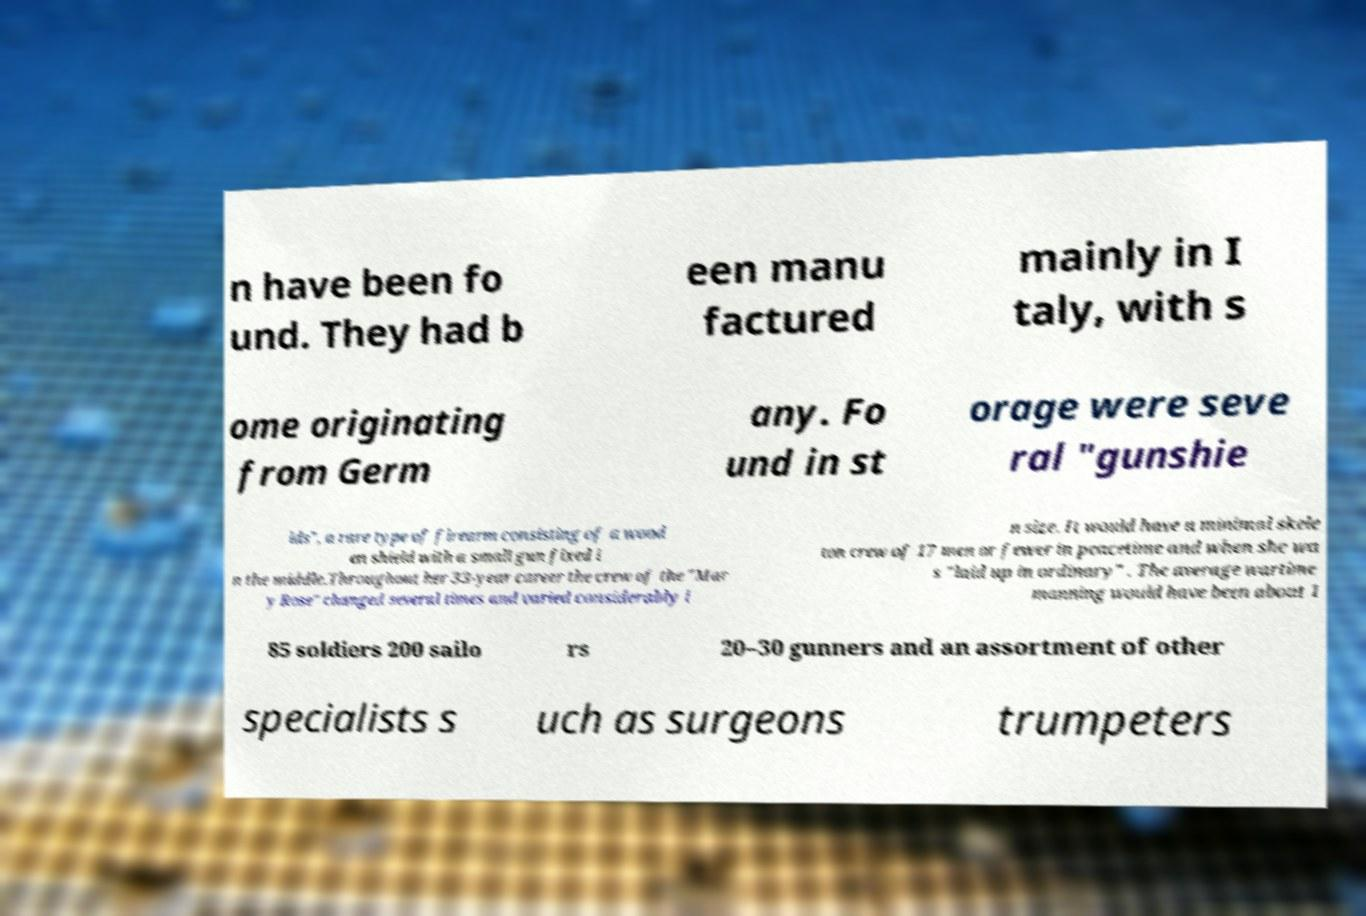Could you extract and type out the text from this image? n have been fo und. They had b een manu factured mainly in I taly, with s ome originating from Germ any. Fo und in st orage were seve ral "gunshie lds", a rare type of firearm consisting of a wood en shield with a small gun fixed i n the middle.Throughout her 33-year career the crew of the "Mar y Rose" changed several times and varied considerably i n size. It would have a minimal skele ton crew of 17 men or fewer in peacetime and when she wa s "laid up in ordinary" . The average wartime manning would have been about 1 85 soldiers 200 sailo rs 20–30 gunners and an assortment of other specialists s uch as surgeons trumpeters 